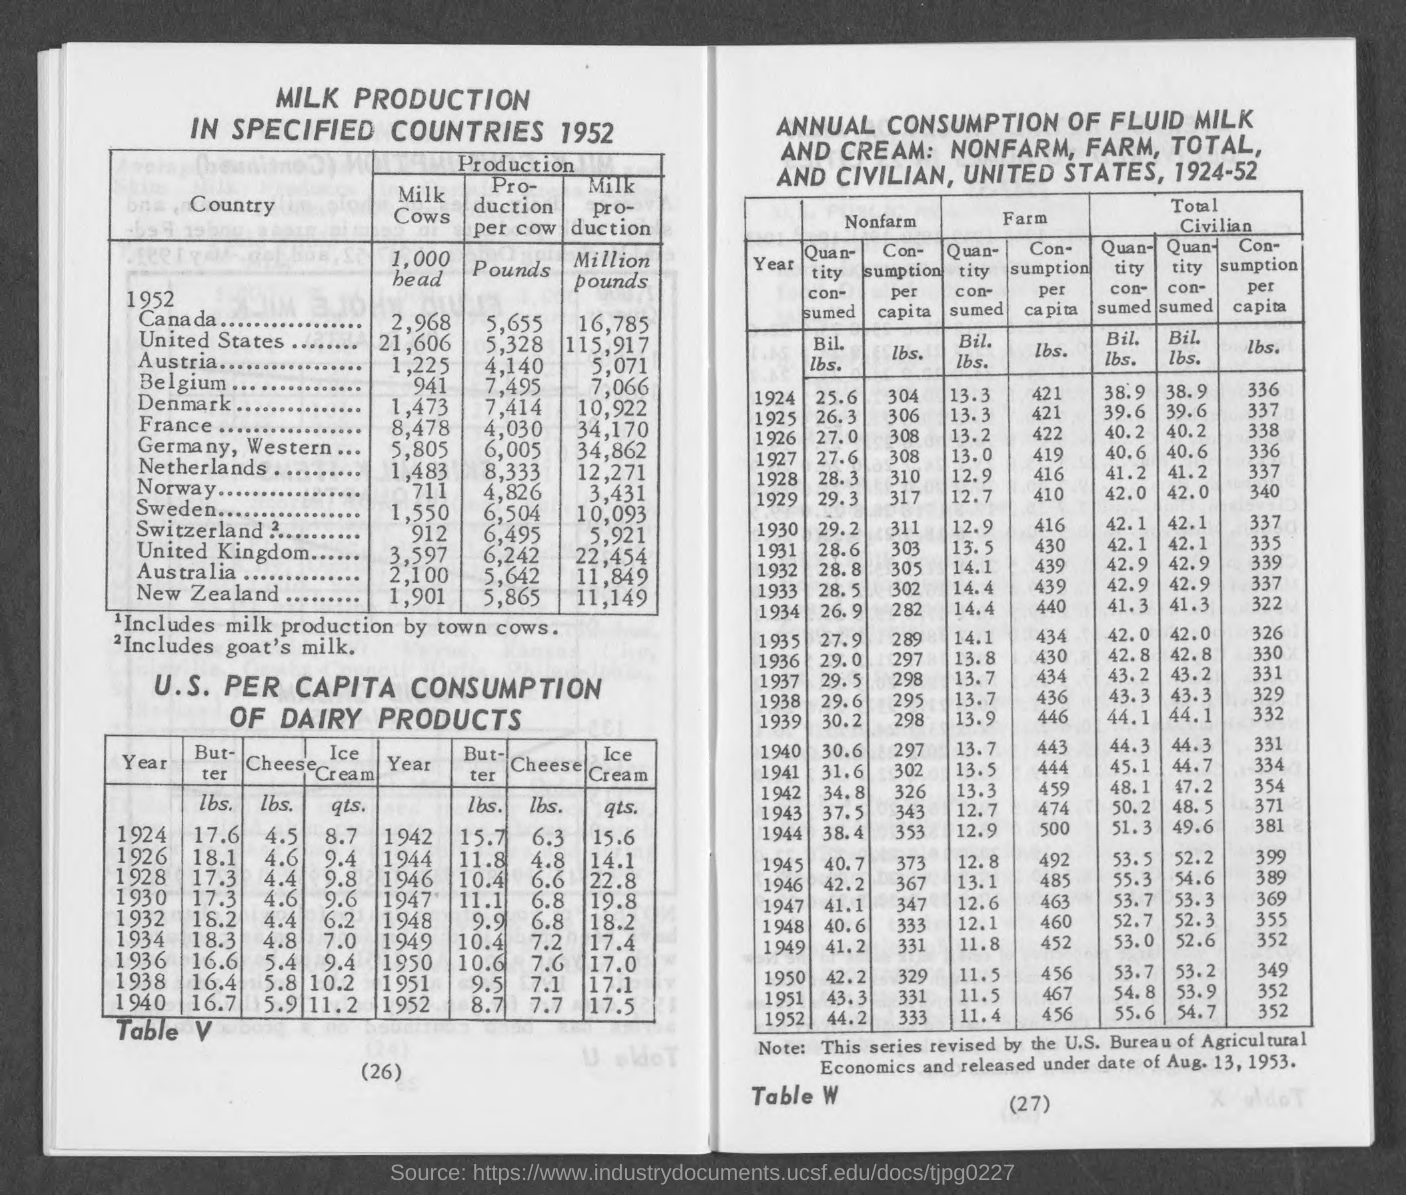What is the number at bottom left page ?
Give a very brief answer. 26. What is the number at bottom of right page ?
Offer a terse response. 27. What is the production per cow in canada?
Your response must be concise. 5,655 pounds. What is the production per cow in  united states ?
Your answer should be very brief. 5,328 pounds. What is the production per cow in austria ?
Ensure brevity in your answer.  4,140 pounds. What is the production per cow in belgium?
Ensure brevity in your answer.  7,495 pounds. What is the production per cow in denmark ?
Make the answer very short. 7,414. What is the production per cow in france ?
Ensure brevity in your answer.  4,030. What is the production per cow in germany, western?
Give a very brief answer. 6,005. What is the production per cow in netherlands ?
Provide a short and direct response. 8,333 pounds. 